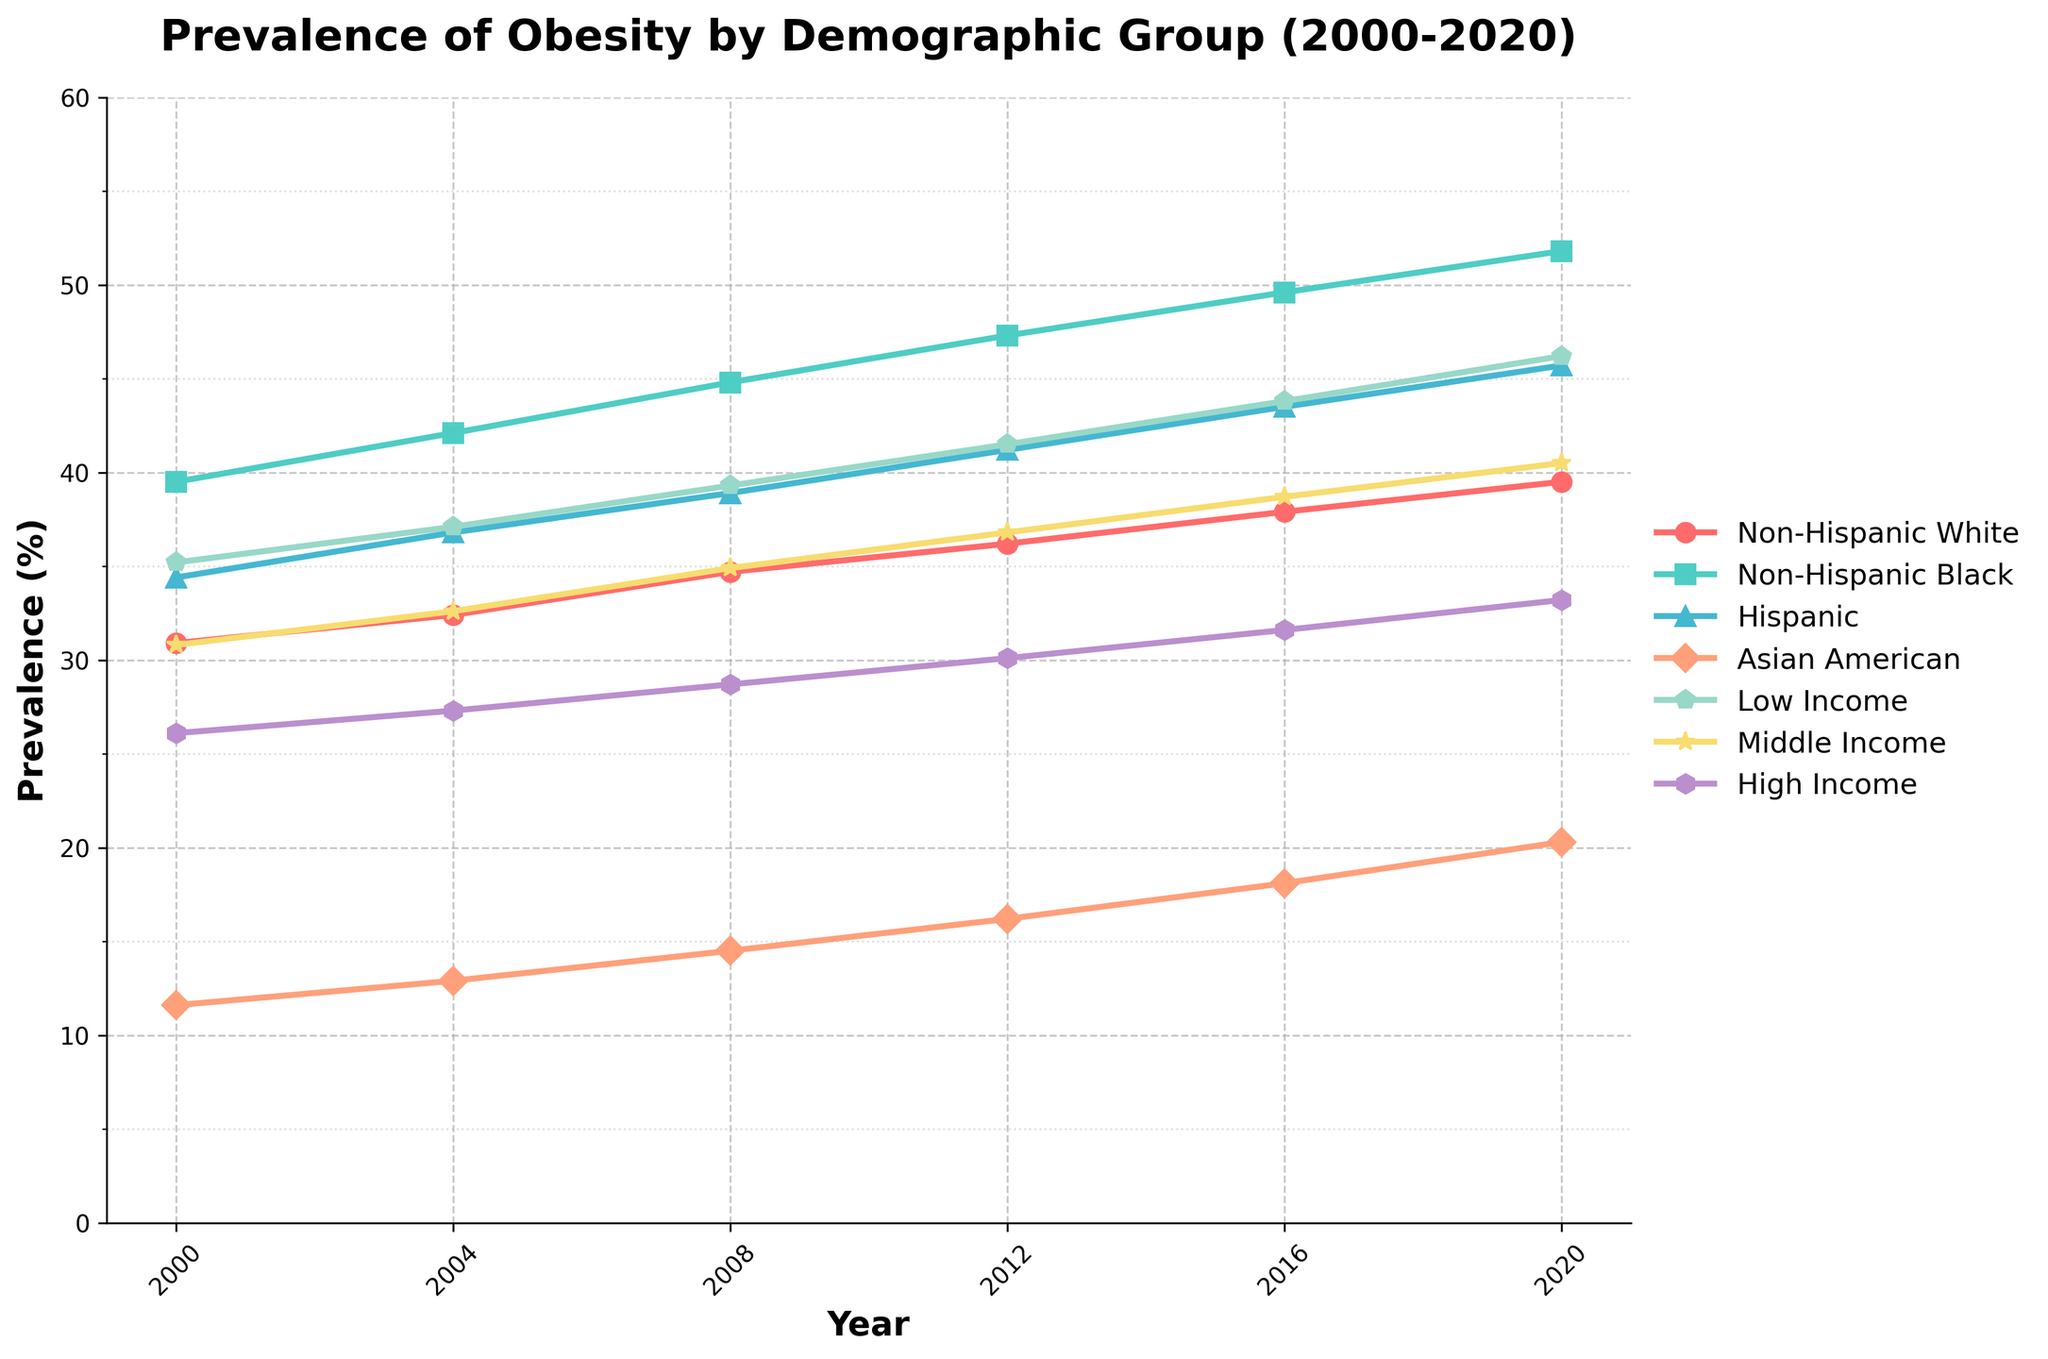What was the prevalence of obesity among Non-Hispanic Black individuals in 2020? To find the prevalence of obesity among Non-Hispanic Black individuals in 2020, locate the "Non-Hispanic Black" line and look at the value corresponding to the year 2020.
Answer: 51.8% Which demographic group had the lowest obesity prevalence in 2000? The lowest obesity prevalence in 2000 is shown by the shortest line in 2000. The "Asian American" group had the lowest rate of 11.6%.
Answer: Asian American What is the difference in obesity prevalence between Non-Hispanic White and Hispanic individuals in 2008? Find the values for Non-Hispanic White and Hispanic individuals in 2008; Non-Hispanic White is 34.7% and Hispanic is 38.9%. Subtract these values: 38.9% - 34.7% = 4.2%.
Answer: 4.2% How much did the obesity prevalence increase for Low-Income individuals from 2000 to 2020? Find the values for Low-Income individuals in 2000 and 2020; the values are 35.2% (2000) and 46.2% (2020). Subtract the initial value from the final value: 46.2% - 35.2% = 11%.
Answer: 11% Which group showed the highest obesity prevalence in 2016? Identify the line with the highest value in 2016. The "Non-Hispanic Black" group had the highest obesity prevalence with 49.6%.
Answer: Non-Hispanic Black Did Middle-Income individuals have a higher or lower obesity prevalence than High-Income individuals in 2012? Compare the values for Middle-Income (36.8%) and High-Income (30.1%) individuals in 2012. Middle-Income values are higher.
Answer: Higher What is the average obesity prevalence of Hispanic individuals over the 20-year period? Add the values for Hispanic individuals from each year and divide by the number of years: (34.4+36.8+38.9+41.2+43.5+45.7)/6 = 40.0833%.
Answer: 40.1% Which group had the steepest increase in obesity prevalence from 2000 to 2020? Compare the rise in values for each demographic group from 2000 to 2020. The "Non-Hispanic Black" group went from 39.5% to 51.8%, the steepest increase of 12.3 percentage points.
Answer: Non-Hispanic Black What is the trend in obesity prevalence among Asian Americans from 2000 to 2020? Identify the pattern in the "Asian American" line from 2000 (11.6%) to 2020 (20.3%). The trend shows a consistent increase in obesity prevalence over the years.
Answer: Increasing How does the obesity prevalence of Low-Income individuals in 2004 compare to that of Non-Hispanic White individuals in the same year? Find the values for Low-Income individuals (37.1%) and Non-Hispanic White individuals (32.4%) in 2004. Low-Income prevalence is higher.
Answer: Higher 